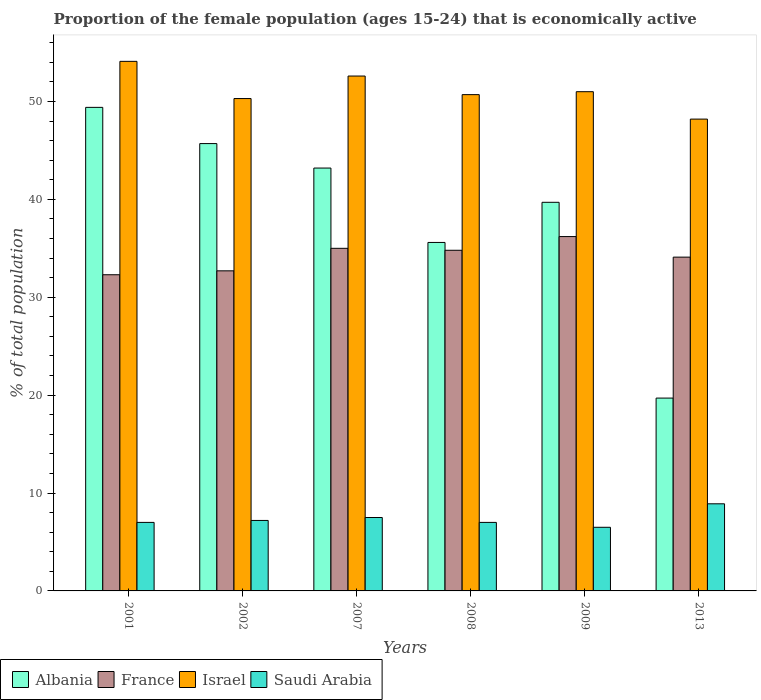How many different coloured bars are there?
Your answer should be compact. 4. How many groups of bars are there?
Your answer should be very brief. 6. In how many cases, is the number of bars for a given year not equal to the number of legend labels?
Provide a succinct answer. 0. What is the proportion of the female population that is economically active in Israel in 2002?
Make the answer very short. 50.3. Across all years, what is the maximum proportion of the female population that is economically active in France?
Ensure brevity in your answer.  36.2. Across all years, what is the minimum proportion of the female population that is economically active in France?
Make the answer very short. 32.3. In which year was the proportion of the female population that is economically active in France maximum?
Your answer should be very brief. 2009. What is the total proportion of the female population that is economically active in Saudi Arabia in the graph?
Your answer should be very brief. 44.1. What is the difference between the proportion of the female population that is economically active in Saudi Arabia in 2001 and that in 2007?
Your answer should be very brief. -0.5. What is the difference between the proportion of the female population that is economically active in Israel in 2008 and the proportion of the female population that is economically active in Saudi Arabia in 2007?
Your answer should be very brief. 43.2. What is the average proportion of the female population that is economically active in Albania per year?
Provide a short and direct response. 38.88. In the year 2001, what is the difference between the proportion of the female population that is economically active in Israel and proportion of the female population that is economically active in Saudi Arabia?
Keep it short and to the point. 47.1. In how many years, is the proportion of the female population that is economically active in Albania greater than 50 %?
Provide a short and direct response. 0. What is the ratio of the proportion of the female population that is economically active in France in 2002 to that in 2013?
Make the answer very short. 0.96. Is the proportion of the female population that is economically active in France in 2001 less than that in 2009?
Provide a short and direct response. Yes. What is the difference between the highest and the second highest proportion of the female population that is economically active in Israel?
Provide a succinct answer. 1.5. What is the difference between the highest and the lowest proportion of the female population that is economically active in Albania?
Keep it short and to the point. 29.7. In how many years, is the proportion of the female population that is economically active in Saudi Arabia greater than the average proportion of the female population that is economically active in Saudi Arabia taken over all years?
Provide a succinct answer. 2. What does the 4th bar from the right in 2001 represents?
Provide a succinct answer. Albania. How many bars are there?
Provide a succinct answer. 24. Are all the bars in the graph horizontal?
Provide a succinct answer. No. How many years are there in the graph?
Offer a terse response. 6. What is the difference between two consecutive major ticks on the Y-axis?
Your response must be concise. 10. Are the values on the major ticks of Y-axis written in scientific E-notation?
Your answer should be compact. No. How are the legend labels stacked?
Your answer should be compact. Horizontal. What is the title of the graph?
Your answer should be very brief. Proportion of the female population (ages 15-24) that is economically active. What is the label or title of the Y-axis?
Your answer should be compact. % of total population. What is the % of total population in Albania in 2001?
Make the answer very short. 49.4. What is the % of total population of France in 2001?
Your answer should be very brief. 32.3. What is the % of total population in Israel in 2001?
Your answer should be very brief. 54.1. What is the % of total population of Albania in 2002?
Offer a very short reply. 45.7. What is the % of total population in France in 2002?
Provide a short and direct response. 32.7. What is the % of total population of Israel in 2002?
Provide a short and direct response. 50.3. What is the % of total population in Saudi Arabia in 2002?
Provide a succinct answer. 7.2. What is the % of total population of Albania in 2007?
Your answer should be compact. 43.2. What is the % of total population of France in 2007?
Your answer should be compact. 35. What is the % of total population of Israel in 2007?
Your answer should be very brief. 52.6. What is the % of total population in Albania in 2008?
Make the answer very short. 35.6. What is the % of total population of France in 2008?
Keep it short and to the point. 34.8. What is the % of total population of Israel in 2008?
Provide a succinct answer. 50.7. What is the % of total population in Saudi Arabia in 2008?
Keep it short and to the point. 7. What is the % of total population of Albania in 2009?
Your answer should be very brief. 39.7. What is the % of total population of France in 2009?
Make the answer very short. 36.2. What is the % of total population in Albania in 2013?
Offer a very short reply. 19.7. What is the % of total population of France in 2013?
Provide a short and direct response. 34.1. What is the % of total population in Israel in 2013?
Your answer should be very brief. 48.2. What is the % of total population in Saudi Arabia in 2013?
Your answer should be very brief. 8.9. Across all years, what is the maximum % of total population of Albania?
Ensure brevity in your answer.  49.4. Across all years, what is the maximum % of total population of France?
Offer a terse response. 36.2. Across all years, what is the maximum % of total population of Israel?
Give a very brief answer. 54.1. Across all years, what is the maximum % of total population in Saudi Arabia?
Give a very brief answer. 8.9. Across all years, what is the minimum % of total population in Albania?
Give a very brief answer. 19.7. Across all years, what is the minimum % of total population of France?
Offer a very short reply. 32.3. Across all years, what is the minimum % of total population of Israel?
Your response must be concise. 48.2. Across all years, what is the minimum % of total population of Saudi Arabia?
Your response must be concise. 6.5. What is the total % of total population in Albania in the graph?
Your answer should be compact. 233.3. What is the total % of total population of France in the graph?
Provide a succinct answer. 205.1. What is the total % of total population of Israel in the graph?
Make the answer very short. 306.9. What is the total % of total population in Saudi Arabia in the graph?
Ensure brevity in your answer.  44.1. What is the difference between the % of total population in Albania in 2001 and that in 2002?
Make the answer very short. 3.7. What is the difference between the % of total population in France in 2001 and that in 2002?
Your response must be concise. -0.4. What is the difference between the % of total population of Albania in 2001 and that in 2007?
Your response must be concise. 6.2. What is the difference between the % of total population of Saudi Arabia in 2001 and that in 2007?
Keep it short and to the point. -0.5. What is the difference between the % of total population of France in 2001 and that in 2008?
Provide a short and direct response. -2.5. What is the difference between the % of total population of Israel in 2001 and that in 2008?
Give a very brief answer. 3.4. What is the difference between the % of total population of Albania in 2001 and that in 2009?
Offer a very short reply. 9.7. What is the difference between the % of total population in France in 2001 and that in 2009?
Offer a very short reply. -3.9. What is the difference between the % of total population of Israel in 2001 and that in 2009?
Your answer should be compact. 3.1. What is the difference between the % of total population of Albania in 2001 and that in 2013?
Keep it short and to the point. 29.7. What is the difference between the % of total population in Saudi Arabia in 2001 and that in 2013?
Make the answer very short. -1.9. What is the difference between the % of total population in Albania in 2002 and that in 2007?
Provide a succinct answer. 2.5. What is the difference between the % of total population in Saudi Arabia in 2002 and that in 2007?
Offer a very short reply. -0.3. What is the difference between the % of total population of Israel in 2002 and that in 2008?
Ensure brevity in your answer.  -0.4. What is the difference between the % of total population of Saudi Arabia in 2002 and that in 2008?
Your answer should be very brief. 0.2. What is the difference between the % of total population in Albania in 2002 and that in 2009?
Make the answer very short. 6. What is the difference between the % of total population in Israel in 2002 and that in 2009?
Your answer should be compact. -0.7. What is the difference between the % of total population in Albania in 2002 and that in 2013?
Provide a short and direct response. 26. What is the difference between the % of total population of Saudi Arabia in 2002 and that in 2013?
Keep it short and to the point. -1.7. What is the difference between the % of total population of Albania in 2007 and that in 2008?
Your answer should be compact. 7.6. What is the difference between the % of total population of Israel in 2007 and that in 2008?
Ensure brevity in your answer.  1.9. What is the difference between the % of total population of Albania in 2007 and that in 2009?
Provide a short and direct response. 3.5. What is the difference between the % of total population in Israel in 2007 and that in 2009?
Your answer should be compact. 1.6. What is the difference between the % of total population of Saudi Arabia in 2007 and that in 2009?
Your answer should be compact. 1. What is the difference between the % of total population of Albania in 2007 and that in 2013?
Keep it short and to the point. 23.5. What is the difference between the % of total population in Saudi Arabia in 2007 and that in 2013?
Make the answer very short. -1.4. What is the difference between the % of total population in Albania in 2008 and that in 2013?
Provide a succinct answer. 15.9. What is the difference between the % of total population in Saudi Arabia in 2008 and that in 2013?
Keep it short and to the point. -1.9. What is the difference between the % of total population of Albania in 2001 and the % of total population of France in 2002?
Your answer should be compact. 16.7. What is the difference between the % of total population in Albania in 2001 and the % of total population in Israel in 2002?
Give a very brief answer. -0.9. What is the difference between the % of total population of Albania in 2001 and the % of total population of Saudi Arabia in 2002?
Your answer should be compact. 42.2. What is the difference between the % of total population in France in 2001 and the % of total population in Saudi Arabia in 2002?
Your answer should be very brief. 25.1. What is the difference between the % of total population in Israel in 2001 and the % of total population in Saudi Arabia in 2002?
Your answer should be very brief. 46.9. What is the difference between the % of total population of Albania in 2001 and the % of total population of Israel in 2007?
Offer a very short reply. -3.2. What is the difference between the % of total population of Albania in 2001 and the % of total population of Saudi Arabia in 2007?
Make the answer very short. 41.9. What is the difference between the % of total population in France in 2001 and the % of total population in Israel in 2007?
Keep it short and to the point. -20.3. What is the difference between the % of total population in France in 2001 and the % of total population in Saudi Arabia in 2007?
Your answer should be compact. 24.8. What is the difference between the % of total population of Israel in 2001 and the % of total population of Saudi Arabia in 2007?
Make the answer very short. 46.6. What is the difference between the % of total population of Albania in 2001 and the % of total population of France in 2008?
Provide a succinct answer. 14.6. What is the difference between the % of total population of Albania in 2001 and the % of total population of Saudi Arabia in 2008?
Make the answer very short. 42.4. What is the difference between the % of total population in France in 2001 and the % of total population in Israel in 2008?
Provide a short and direct response. -18.4. What is the difference between the % of total population of France in 2001 and the % of total population of Saudi Arabia in 2008?
Give a very brief answer. 25.3. What is the difference between the % of total population of Israel in 2001 and the % of total population of Saudi Arabia in 2008?
Your answer should be compact. 47.1. What is the difference between the % of total population in Albania in 2001 and the % of total population in Israel in 2009?
Provide a succinct answer. -1.6. What is the difference between the % of total population of Albania in 2001 and the % of total population of Saudi Arabia in 2009?
Make the answer very short. 42.9. What is the difference between the % of total population in France in 2001 and the % of total population in Israel in 2009?
Your answer should be very brief. -18.7. What is the difference between the % of total population of France in 2001 and the % of total population of Saudi Arabia in 2009?
Your answer should be very brief. 25.8. What is the difference between the % of total population of Israel in 2001 and the % of total population of Saudi Arabia in 2009?
Your answer should be very brief. 47.6. What is the difference between the % of total population of Albania in 2001 and the % of total population of France in 2013?
Keep it short and to the point. 15.3. What is the difference between the % of total population in Albania in 2001 and the % of total population in Israel in 2013?
Give a very brief answer. 1.2. What is the difference between the % of total population of Albania in 2001 and the % of total population of Saudi Arabia in 2013?
Your answer should be very brief. 40.5. What is the difference between the % of total population in France in 2001 and the % of total population in Israel in 2013?
Ensure brevity in your answer.  -15.9. What is the difference between the % of total population of France in 2001 and the % of total population of Saudi Arabia in 2013?
Provide a succinct answer. 23.4. What is the difference between the % of total population of Israel in 2001 and the % of total population of Saudi Arabia in 2013?
Provide a short and direct response. 45.2. What is the difference between the % of total population in Albania in 2002 and the % of total population in France in 2007?
Provide a succinct answer. 10.7. What is the difference between the % of total population in Albania in 2002 and the % of total population in Israel in 2007?
Keep it short and to the point. -6.9. What is the difference between the % of total population of Albania in 2002 and the % of total population of Saudi Arabia in 2007?
Provide a succinct answer. 38.2. What is the difference between the % of total population of France in 2002 and the % of total population of Israel in 2007?
Give a very brief answer. -19.9. What is the difference between the % of total population of France in 2002 and the % of total population of Saudi Arabia in 2007?
Offer a very short reply. 25.2. What is the difference between the % of total population in Israel in 2002 and the % of total population in Saudi Arabia in 2007?
Make the answer very short. 42.8. What is the difference between the % of total population of Albania in 2002 and the % of total population of France in 2008?
Your answer should be compact. 10.9. What is the difference between the % of total population in Albania in 2002 and the % of total population in Saudi Arabia in 2008?
Your answer should be very brief. 38.7. What is the difference between the % of total population of France in 2002 and the % of total population of Israel in 2008?
Offer a very short reply. -18. What is the difference between the % of total population of France in 2002 and the % of total population of Saudi Arabia in 2008?
Keep it short and to the point. 25.7. What is the difference between the % of total population of Israel in 2002 and the % of total population of Saudi Arabia in 2008?
Give a very brief answer. 43.3. What is the difference between the % of total population in Albania in 2002 and the % of total population in France in 2009?
Make the answer very short. 9.5. What is the difference between the % of total population of Albania in 2002 and the % of total population of Israel in 2009?
Make the answer very short. -5.3. What is the difference between the % of total population in Albania in 2002 and the % of total population in Saudi Arabia in 2009?
Keep it short and to the point. 39.2. What is the difference between the % of total population in France in 2002 and the % of total population in Israel in 2009?
Give a very brief answer. -18.3. What is the difference between the % of total population of France in 2002 and the % of total population of Saudi Arabia in 2009?
Your answer should be very brief. 26.2. What is the difference between the % of total population of Israel in 2002 and the % of total population of Saudi Arabia in 2009?
Your answer should be compact. 43.8. What is the difference between the % of total population in Albania in 2002 and the % of total population in Saudi Arabia in 2013?
Provide a short and direct response. 36.8. What is the difference between the % of total population of France in 2002 and the % of total population of Israel in 2013?
Your answer should be very brief. -15.5. What is the difference between the % of total population in France in 2002 and the % of total population in Saudi Arabia in 2013?
Give a very brief answer. 23.8. What is the difference between the % of total population in Israel in 2002 and the % of total population in Saudi Arabia in 2013?
Your answer should be very brief. 41.4. What is the difference between the % of total population of Albania in 2007 and the % of total population of France in 2008?
Make the answer very short. 8.4. What is the difference between the % of total population of Albania in 2007 and the % of total population of Saudi Arabia in 2008?
Keep it short and to the point. 36.2. What is the difference between the % of total population in France in 2007 and the % of total population in Israel in 2008?
Keep it short and to the point. -15.7. What is the difference between the % of total population in Israel in 2007 and the % of total population in Saudi Arabia in 2008?
Your answer should be compact. 45.6. What is the difference between the % of total population of Albania in 2007 and the % of total population of Saudi Arabia in 2009?
Your response must be concise. 36.7. What is the difference between the % of total population in Israel in 2007 and the % of total population in Saudi Arabia in 2009?
Your answer should be compact. 46.1. What is the difference between the % of total population of Albania in 2007 and the % of total population of Israel in 2013?
Offer a very short reply. -5. What is the difference between the % of total population in Albania in 2007 and the % of total population in Saudi Arabia in 2013?
Your answer should be compact. 34.3. What is the difference between the % of total population of France in 2007 and the % of total population of Israel in 2013?
Your answer should be very brief. -13.2. What is the difference between the % of total population in France in 2007 and the % of total population in Saudi Arabia in 2013?
Offer a very short reply. 26.1. What is the difference between the % of total population of Israel in 2007 and the % of total population of Saudi Arabia in 2013?
Offer a terse response. 43.7. What is the difference between the % of total population of Albania in 2008 and the % of total population of Israel in 2009?
Your answer should be compact. -15.4. What is the difference between the % of total population of Albania in 2008 and the % of total population of Saudi Arabia in 2009?
Give a very brief answer. 29.1. What is the difference between the % of total population in France in 2008 and the % of total population in Israel in 2009?
Ensure brevity in your answer.  -16.2. What is the difference between the % of total population of France in 2008 and the % of total population of Saudi Arabia in 2009?
Your answer should be very brief. 28.3. What is the difference between the % of total population of Israel in 2008 and the % of total population of Saudi Arabia in 2009?
Keep it short and to the point. 44.2. What is the difference between the % of total population in Albania in 2008 and the % of total population in France in 2013?
Offer a terse response. 1.5. What is the difference between the % of total population in Albania in 2008 and the % of total population in Saudi Arabia in 2013?
Your answer should be very brief. 26.7. What is the difference between the % of total population of France in 2008 and the % of total population of Israel in 2013?
Keep it short and to the point. -13.4. What is the difference between the % of total population of France in 2008 and the % of total population of Saudi Arabia in 2013?
Ensure brevity in your answer.  25.9. What is the difference between the % of total population in Israel in 2008 and the % of total population in Saudi Arabia in 2013?
Your answer should be very brief. 41.8. What is the difference between the % of total population in Albania in 2009 and the % of total population in France in 2013?
Your answer should be compact. 5.6. What is the difference between the % of total population in Albania in 2009 and the % of total population in Israel in 2013?
Your answer should be compact. -8.5. What is the difference between the % of total population in Albania in 2009 and the % of total population in Saudi Arabia in 2013?
Give a very brief answer. 30.8. What is the difference between the % of total population of France in 2009 and the % of total population of Saudi Arabia in 2013?
Offer a terse response. 27.3. What is the difference between the % of total population of Israel in 2009 and the % of total population of Saudi Arabia in 2013?
Make the answer very short. 42.1. What is the average % of total population in Albania per year?
Your answer should be compact. 38.88. What is the average % of total population in France per year?
Offer a very short reply. 34.18. What is the average % of total population of Israel per year?
Provide a succinct answer. 51.15. What is the average % of total population in Saudi Arabia per year?
Give a very brief answer. 7.35. In the year 2001, what is the difference between the % of total population of Albania and % of total population of Saudi Arabia?
Your answer should be very brief. 42.4. In the year 2001, what is the difference between the % of total population in France and % of total population in Israel?
Offer a terse response. -21.8. In the year 2001, what is the difference between the % of total population in France and % of total population in Saudi Arabia?
Offer a terse response. 25.3. In the year 2001, what is the difference between the % of total population in Israel and % of total population in Saudi Arabia?
Your answer should be very brief. 47.1. In the year 2002, what is the difference between the % of total population in Albania and % of total population in France?
Give a very brief answer. 13. In the year 2002, what is the difference between the % of total population in Albania and % of total population in Saudi Arabia?
Your response must be concise. 38.5. In the year 2002, what is the difference between the % of total population in France and % of total population in Israel?
Your response must be concise. -17.6. In the year 2002, what is the difference between the % of total population in France and % of total population in Saudi Arabia?
Give a very brief answer. 25.5. In the year 2002, what is the difference between the % of total population of Israel and % of total population of Saudi Arabia?
Your answer should be compact. 43.1. In the year 2007, what is the difference between the % of total population in Albania and % of total population in Israel?
Provide a short and direct response. -9.4. In the year 2007, what is the difference between the % of total population in Albania and % of total population in Saudi Arabia?
Your response must be concise. 35.7. In the year 2007, what is the difference between the % of total population of France and % of total population of Israel?
Keep it short and to the point. -17.6. In the year 2007, what is the difference between the % of total population of France and % of total population of Saudi Arabia?
Your answer should be very brief. 27.5. In the year 2007, what is the difference between the % of total population of Israel and % of total population of Saudi Arabia?
Provide a short and direct response. 45.1. In the year 2008, what is the difference between the % of total population of Albania and % of total population of France?
Ensure brevity in your answer.  0.8. In the year 2008, what is the difference between the % of total population in Albania and % of total population in Israel?
Provide a succinct answer. -15.1. In the year 2008, what is the difference between the % of total population of Albania and % of total population of Saudi Arabia?
Offer a terse response. 28.6. In the year 2008, what is the difference between the % of total population in France and % of total population in Israel?
Your answer should be compact. -15.9. In the year 2008, what is the difference between the % of total population of France and % of total population of Saudi Arabia?
Keep it short and to the point. 27.8. In the year 2008, what is the difference between the % of total population of Israel and % of total population of Saudi Arabia?
Make the answer very short. 43.7. In the year 2009, what is the difference between the % of total population in Albania and % of total population in Israel?
Provide a short and direct response. -11.3. In the year 2009, what is the difference between the % of total population of Albania and % of total population of Saudi Arabia?
Your answer should be very brief. 33.2. In the year 2009, what is the difference between the % of total population of France and % of total population of Israel?
Offer a very short reply. -14.8. In the year 2009, what is the difference between the % of total population of France and % of total population of Saudi Arabia?
Your answer should be very brief. 29.7. In the year 2009, what is the difference between the % of total population of Israel and % of total population of Saudi Arabia?
Provide a succinct answer. 44.5. In the year 2013, what is the difference between the % of total population of Albania and % of total population of France?
Provide a succinct answer. -14.4. In the year 2013, what is the difference between the % of total population of Albania and % of total population of Israel?
Your answer should be compact. -28.5. In the year 2013, what is the difference between the % of total population of Albania and % of total population of Saudi Arabia?
Your response must be concise. 10.8. In the year 2013, what is the difference between the % of total population of France and % of total population of Israel?
Make the answer very short. -14.1. In the year 2013, what is the difference between the % of total population of France and % of total population of Saudi Arabia?
Give a very brief answer. 25.2. In the year 2013, what is the difference between the % of total population of Israel and % of total population of Saudi Arabia?
Ensure brevity in your answer.  39.3. What is the ratio of the % of total population of Albania in 2001 to that in 2002?
Offer a terse response. 1.08. What is the ratio of the % of total population of France in 2001 to that in 2002?
Keep it short and to the point. 0.99. What is the ratio of the % of total population in Israel in 2001 to that in 2002?
Give a very brief answer. 1.08. What is the ratio of the % of total population of Saudi Arabia in 2001 to that in 2002?
Offer a very short reply. 0.97. What is the ratio of the % of total population of Albania in 2001 to that in 2007?
Give a very brief answer. 1.14. What is the ratio of the % of total population in France in 2001 to that in 2007?
Ensure brevity in your answer.  0.92. What is the ratio of the % of total population of Israel in 2001 to that in 2007?
Make the answer very short. 1.03. What is the ratio of the % of total population in Albania in 2001 to that in 2008?
Make the answer very short. 1.39. What is the ratio of the % of total population of France in 2001 to that in 2008?
Offer a very short reply. 0.93. What is the ratio of the % of total population in Israel in 2001 to that in 2008?
Your answer should be compact. 1.07. What is the ratio of the % of total population in Albania in 2001 to that in 2009?
Make the answer very short. 1.24. What is the ratio of the % of total population in France in 2001 to that in 2009?
Provide a short and direct response. 0.89. What is the ratio of the % of total population in Israel in 2001 to that in 2009?
Provide a succinct answer. 1.06. What is the ratio of the % of total population in Saudi Arabia in 2001 to that in 2009?
Your answer should be compact. 1.08. What is the ratio of the % of total population in Albania in 2001 to that in 2013?
Offer a very short reply. 2.51. What is the ratio of the % of total population in France in 2001 to that in 2013?
Your answer should be very brief. 0.95. What is the ratio of the % of total population of Israel in 2001 to that in 2013?
Your response must be concise. 1.12. What is the ratio of the % of total population of Saudi Arabia in 2001 to that in 2013?
Your answer should be very brief. 0.79. What is the ratio of the % of total population of Albania in 2002 to that in 2007?
Your response must be concise. 1.06. What is the ratio of the % of total population in France in 2002 to that in 2007?
Make the answer very short. 0.93. What is the ratio of the % of total population in Israel in 2002 to that in 2007?
Your answer should be compact. 0.96. What is the ratio of the % of total population of Saudi Arabia in 2002 to that in 2007?
Offer a very short reply. 0.96. What is the ratio of the % of total population of Albania in 2002 to that in 2008?
Offer a terse response. 1.28. What is the ratio of the % of total population of France in 2002 to that in 2008?
Your answer should be compact. 0.94. What is the ratio of the % of total population in Saudi Arabia in 2002 to that in 2008?
Provide a short and direct response. 1.03. What is the ratio of the % of total population in Albania in 2002 to that in 2009?
Provide a short and direct response. 1.15. What is the ratio of the % of total population of France in 2002 to that in 2009?
Offer a very short reply. 0.9. What is the ratio of the % of total population of Israel in 2002 to that in 2009?
Make the answer very short. 0.99. What is the ratio of the % of total population of Saudi Arabia in 2002 to that in 2009?
Offer a very short reply. 1.11. What is the ratio of the % of total population of Albania in 2002 to that in 2013?
Give a very brief answer. 2.32. What is the ratio of the % of total population in France in 2002 to that in 2013?
Offer a very short reply. 0.96. What is the ratio of the % of total population of Israel in 2002 to that in 2013?
Your answer should be very brief. 1.04. What is the ratio of the % of total population of Saudi Arabia in 2002 to that in 2013?
Your response must be concise. 0.81. What is the ratio of the % of total population of Albania in 2007 to that in 2008?
Provide a short and direct response. 1.21. What is the ratio of the % of total population of Israel in 2007 to that in 2008?
Your answer should be very brief. 1.04. What is the ratio of the % of total population of Saudi Arabia in 2007 to that in 2008?
Provide a succinct answer. 1.07. What is the ratio of the % of total population in Albania in 2007 to that in 2009?
Your answer should be compact. 1.09. What is the ratio of the % of total population in France in 2007 to that in 2009?
Give a very brief answer. 0.97. What is the ratio of the % of total population in Israel in 2007 to that in 2009?
Give a very brief answer. 1.03. What is the ratio of the % of total population in Saudi Arabia in 2007 to that in 2009?
Offer a terse response. 1.15. What is the ratio of the % of total population in Albania in 2007 to that in 2013?
Offer a very short reply. 2.19. What is the ratio of the % of total population in France in 2007 to that in 2013?
Provide a succinct answer. 1.03. What is the ratio of the % of total population in Israel in 2007 to that in 2013?
Your answer should be compact. 1.09. What is the ratio of the % of total population in Saudi Arabia in 2007 to that in 2013?
Make the answer very short. 0.84. What is the ratio of the % of total population of Albania in 2008 to that in 2009?
Give a very brief answer. 0.9. What is the ratio of the % of total population in France in 2008 to that in 2009?
Your answer should be compact. 0.96. What is the ratio of the % of total population in Israel in 2008 to that in 2009?
Keep it short and to the point. 0.99. What is the ratio of the % of total population of Albania in 2008 to that in 2013?
Provide a succinct answer. 1.81. What is the ratio of the % of total population in France in 2008 to that in 2013?
Keep it short and to the point. 1.02. What is the ratio of the % of total population of Israel in 2008 to that in 2013?
Provide a short and direct response. 1.05. What is the ratio of the % of total population of Saudi Arabia in 2008 to that in 2013?
Provide a succinct answer. 0.79. What is the ratio of the % of total population of Albania in 2009 to that in 2013?
Provide a succinct answer. 2.02. What is the ratio of the % of total population of France in 2009 to that in 2013?
Your answer should be compact. 1.06. What is the ratio of the % of total population in Israel in 2009 to that in 2013?
Keep it short and to the point. 1.06. What is the ratio of the % of total population in Saudi Arabia in 2009 to that in 2013?
Provide a short and direct response. 0.73. What is the difference between the highest and the second highest % of total population of Albania?
Offer a terse response. 3.7. What is the difference between the highest and the second highest % of total population of France?
Your answer should be very brief. 1.2. What is the difference between the highest and the lowest % of total population in Albania?
Give a very brief answer. 29.7. What is the difference between the highest and the lowest % of total population in Saudi Arabia?
Your answer should be compact. 2.4. 